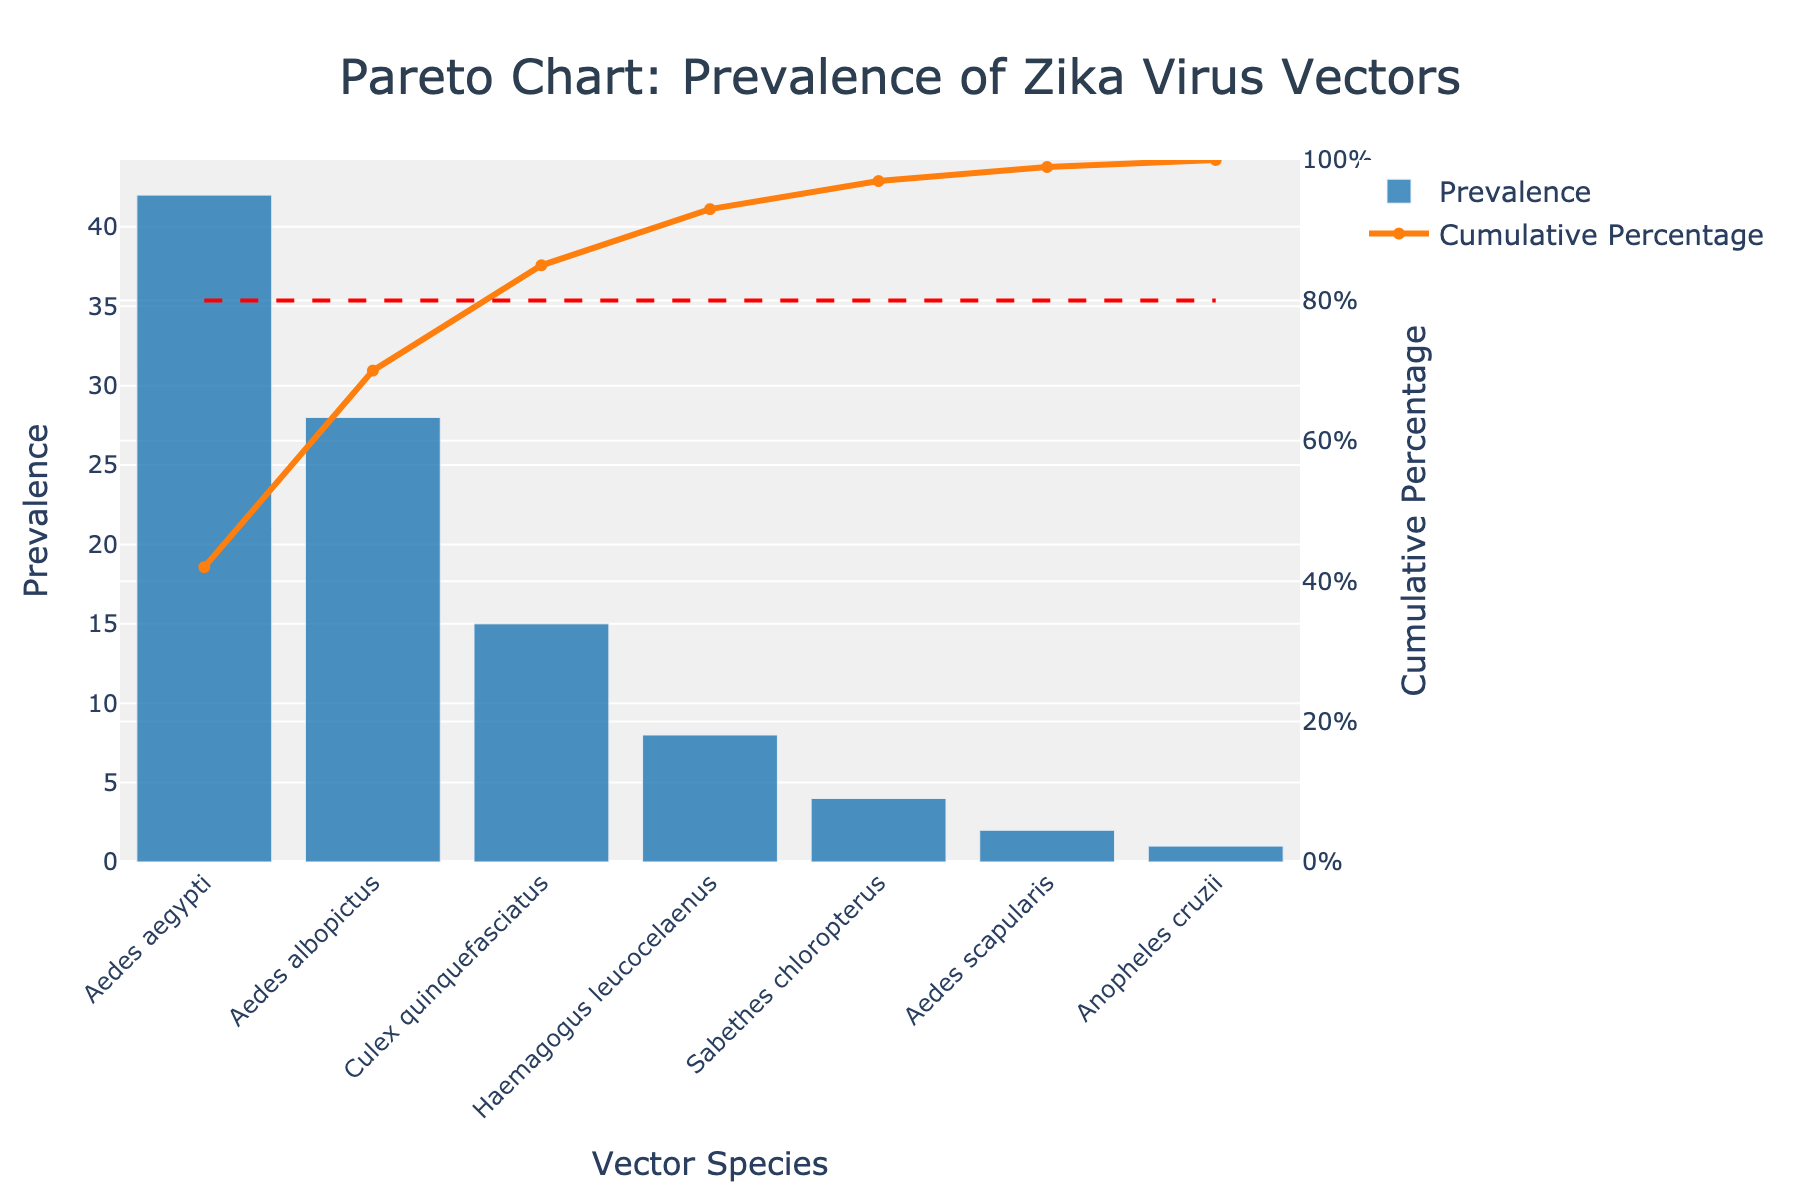What is the title of the chart? The title of the chart is typically placed at the top and labeled clearly. On this chart, it is visible and reads "Pareto Chart: Prevalence of Zika Virus Vectors."
Answer: Pareto Chart: Prevalence of Zika Virus Vectors Which vector has the highest prevalence? The vector with the highest prevalence will have the tallest bar on the bar chart. In this case, "Aedes aegypti" has the tallest bar.
Answer: Aedes aegypti What is the prevalence of Aedes albopictus? To find the prevalence of "Aedes albopictus," look at the height of its bar. From the chart, its bar reaches to the value 28.
Answer: 28 Which vectors account for the cumulative percentage of exactly (or closest to) 80%? To find the vectors that account for close to 80%, observe the cumulative percentage line and find where it intersects with the 80% horizontal line. From the chart, "Aedes aegypti," "Aedes albopictus," and "Culex quinquefasciatus" cumulatively reach close to 80%.
Answer: Aedes aegypti, Aedes albopictus, and Culex quinquefasciatus What is the cumulative percentage after including Haemagogus leucocelaenus? To find this, add the cumulative percentages up to "Haemagogus leucocelaenus." From the chart: Aedes aegypti (42), Aedes albopictus (28), Culex quinquefasciatus (15), and Haemagogus leucocelaenus (8) total to 93/100 or 93%.
Answer: 93% Which vector has the lowest prevalence? The vector with the lowest prevalence will have the shortest bar in the bar chart. "Anopheles cruzii" is the vector with the shortest bar.
Answer: Anopheles cruzii How many vectors have a prevalence greater than 20? Count the bars that are greater than the 20 mark. The vectors "Aedes aegypti" and "Aedes albopictus" have bars that are greater than 20.
Answer: 2 What is the cumulative percentage of the top 3 vectors? Add the cumulative percentages of the top three vectors: "Aedes aegypti" (42), "Aedes albopictus" (28), and "Culex quinquefasciatus" (15). Their total prevalence is 42 + 28 + 15 = 85, and 85/100 is 85%.
Answer: 85% Which vectors contribute to achieving exactly 50% prevalence cumulatively? Look at the cumulative percentage line and determine which vectors’ prevalence contributes to reaching 50%. "Aedes aegypti" and "Aedes albopictus" together add up to 42 + 28 = 70.
Answer: Aedes aegypti, Aedes albopictus What can you infer about the prevalence of vectors other than Aedes aegypti in comparison to their cumulative prevalence percentages? Observe the difference between individual and cumulative prevalences of other vectors compared to "Aedes aegypti." "Aedes aegypti" alone accounts for 42% prevalence, while the percentages for the other vectors are significantly lower and add up to less than "Aedes aegypti" when considered individually; the next highest after cumulatively.
Answer: Other vectors individually have much lower prevalences compared to Aedes aegypti, which alone contributes the highest single percentage to the cumulative prevalence 